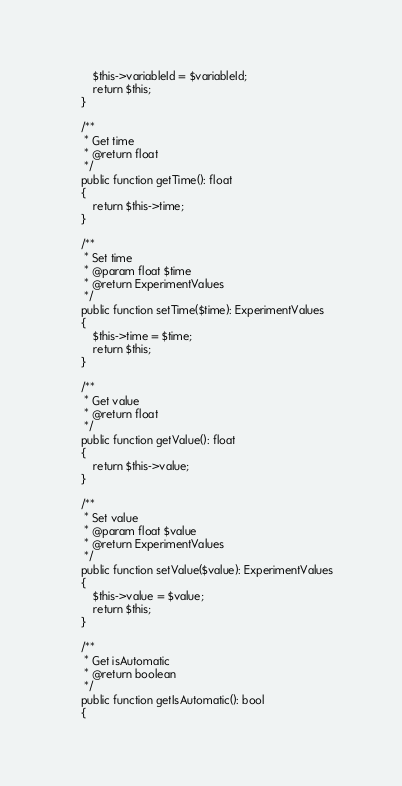<code> <loc_0><loc_0><loc_500><loc_500><_PHP_>		$this->variableId = $variableId;
		return $this;
	}

	/**
	 * Get time
	 * @return float
	 */
	public function getTime(): float
	{
		return $this->time;
	}

	/**
	 * Set time
	 * @param float $time
	 * @return ExperimentValues
	 */
	public function setTime($time): ExperimentValues
	{
		$this->time = $time;
		return $this;
	}

	/**
	 * Get value
	 * @return float
	 */
	public function getValue(): float
	{
		return $this->value;
	}

	/**
	 * Set value
	 * @param float $value
	 * @return ExperimentValues
	 */
	public function setValue($value): ExperimentValues
	{
		$this->value = $value;
		return $this;
	}

    /**
     * Get isAutomatic
     * @return boolean
     */
    public function getIsAutomatic(): bool
    {</code> 